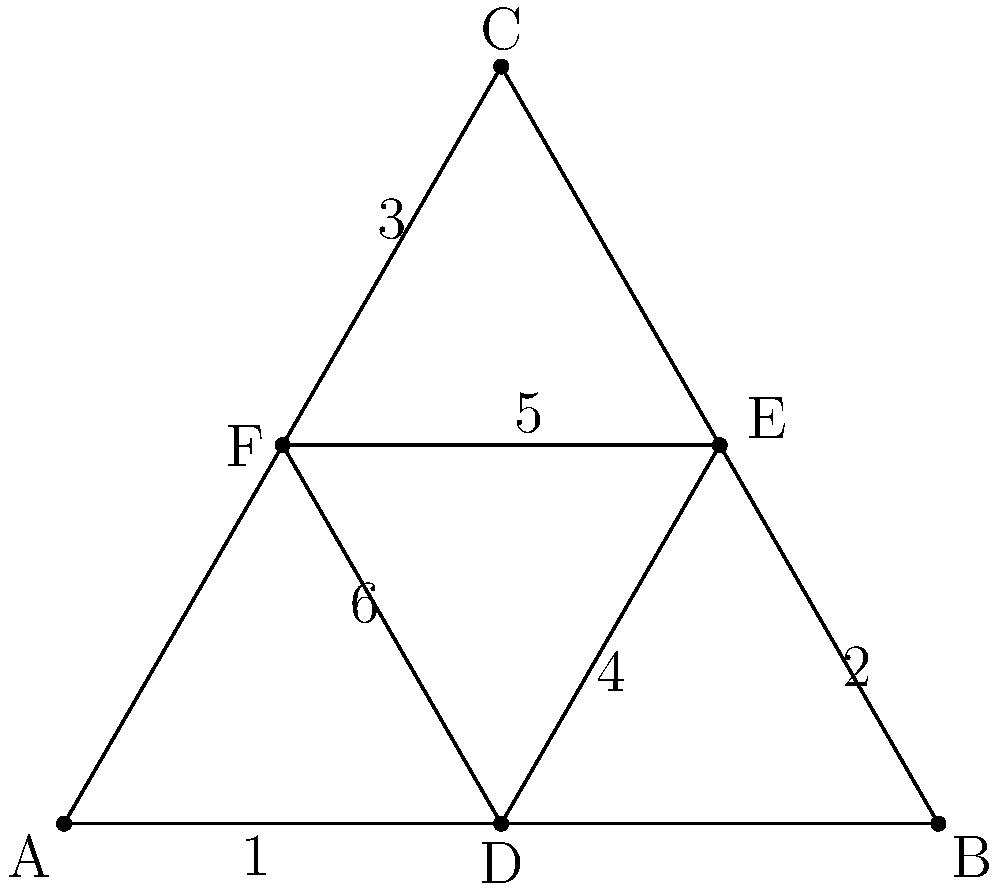In a rugby scrum formation, six players are arranged in a triangular shape as shown in the diagram. The coach wants to rotate the players' positions to ensure equal playing time in different roles. If each rotation involves moving each player to the next position clockwise, how many unique arrangements are possible before returning to the initial formation? Let's approach this step-by-step:

1) First, we need to understand what happens in each rotation:
   - Player 1 moves to position 2
   - Player 2 moves to position 3
   - Player 3 moves to position 4
   - Player 4 moves to position 5
   - Player 5 moves to position 6
   - Player 6 moves to position 1

2) This is a cyclic permutation of 6 elements.

3) In group theory, this is represented by the cycle $(123456)$.

4) To find how many unique arrangements are possible, we need to determine how many times we need to apply this rotation before we get back to the initial arrangement.

5) Mathematically, we're looking for the smallest positive integer $n$ such that $(123456)^n = (1)$ (the identity permutation).

6) This is equivalent to finding the order of the permutation $(123456)$.

7) The order of a cycle is always equal to its length. In this case, the length of the cycle is 6.

Therefore, after 6 rotations, we will return to the initial formation. This means there are 6 unique arrangements (including the initial arrangement) before returning to the starting position.
Answer: 6 unique arrangements 